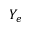<formula> <loc_0><loc_0><loc_500><loc_500>Y _ { e }</formula> 